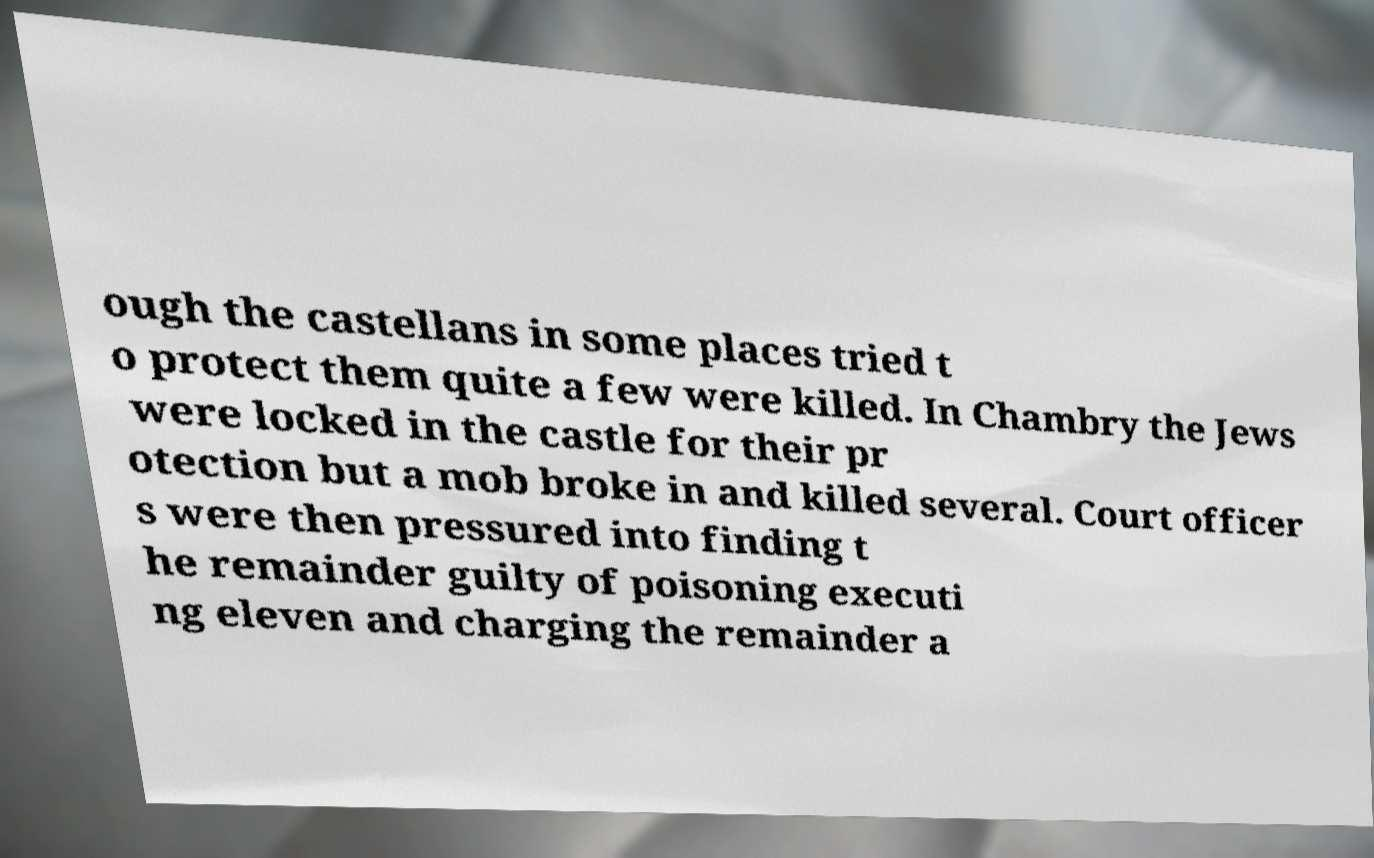Could you extract and type out the text from this image? ough the castellans in some places tried t o protect them quite a few were killed. In Chambry the Jews were locked in the castle for their pr otection but a mob broke in and killed several. Court officer s were then pressured into finding t he remainder guilty of poisoning executi ng eleven and charging the remainder a 